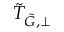<formula> <loc_0><loc_0><loc_500><loc_500>\tilde { T } _ { \tilde { G } , \perp }</formula> 